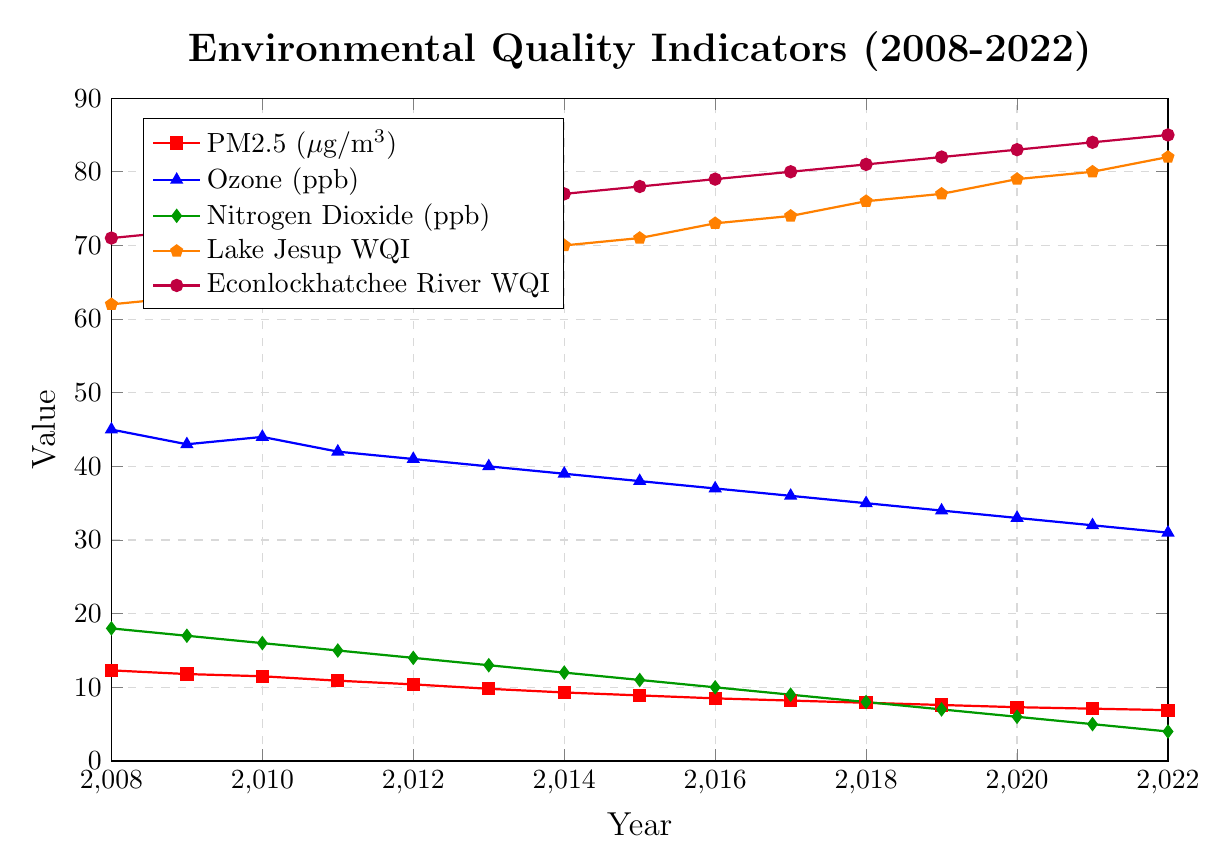What was the value of PM2.5 in 2012? The PM2.5 value for each year is represented by the red line with square markers. From the graph, it shows that the value in 2012 was 10.4 μg/m³.
Answer: 10.4 μg/m³ Which year had the lowest Nitrogen Dioxide level? The Nitrogen Dioxide values are indicated by the green line with diamond markers. The lowest value appears in 2022 with a measurement of 4 ppb.
Answer: 2022 What is the overall trend of Lake Jesup Water Quality Index from 2008 to 2022? The Lake Jesup WQI is represented by an orange line with pentagon markers. From 2008 to 2022, the trend line shows a steady increase from 62 to 82.
Answer: Increasing Compare the values of PM2.5 and Ozone in 2016. Which one was higher? In 2016, PM2.5 is represented by a red square marker, and Ozone by a blue triangle marker. The PM2.5 value is 8.5 μg/m³, and Ozone is 37 ppb. Since 37 is much higher than 8.5, Ozone had a higher value.
Answer: Ozone By how much did the Econlockhatchee River Water Quality Index improve from 2008 to 2022? The Econlockhatchee River WQI is represented by a purple line with circle markers. From 2008 to 2022, the WQI improved from 71 to 85. The amount of improvement can be calculated as 85 - 71 = 14 points.
Answer: 14 points What year had the highest Ozone level, and what was its value? Ozone levels are indicated by the blue line with triangle markers. The highest value appears in 2008, with a measurement of 45 ppb.
Answer: 2008, 45 ppb Which pollutant showed the most significant decrease in value from 2008 to 2022? The most significant decrease can be observed by comparing the starting and ending values of pollutants. PM2.5 decreased from 12.3 to 6.9, Ozone from 45 to 31, and Nitrogen Dioxide from 18 to 4. Nitrogen Dioxide has the most significant decrease (18 - 4 = 14 ppb).
Answer: Nitrogen Dioxide Between 2010 and 2015, how much did the Lake Jesup Water Quality Index change? The Lake Jesup WQI values in 2010 and 2015 are 64 and 71 respectively. The increase can be calculated as 71 - 64 = 7 points.
Answer: 7 points Was the Ozone level higher or lower in 2015 compared to 2008? By how much? The Ozone value in 2008 is 45 ppb and in 2015 it is 38 ppb. The difference is 45 - 38 = 7 ppb. Thus, the level was lower in 2015 by 7 ppb.
Answer: Lower by 7 ppb 